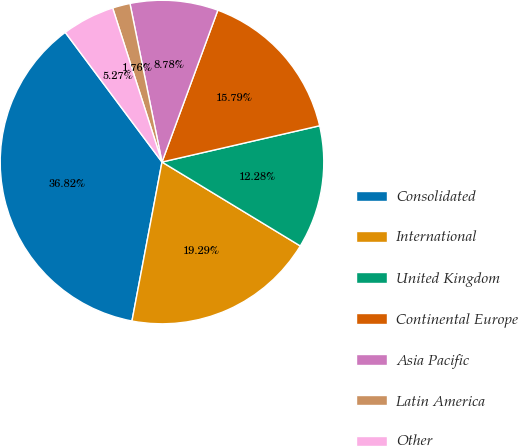Convert chart. <chart><loc_0><loc_0><loc_500><loc_500><pie_chart><fcel>Consolidated<fcel>International<fcel>United Kingdom<fcel>Continental Europe<fcel>Asia Pacific<fcel>Latin America<fcel>Other<nl><fcel>36.82%<fcel>19.29%<fcel>12.28%<fcel>15.79%<fcel>8.78%<fcel>1.76%<fcel>5.27%<nl></chart> 